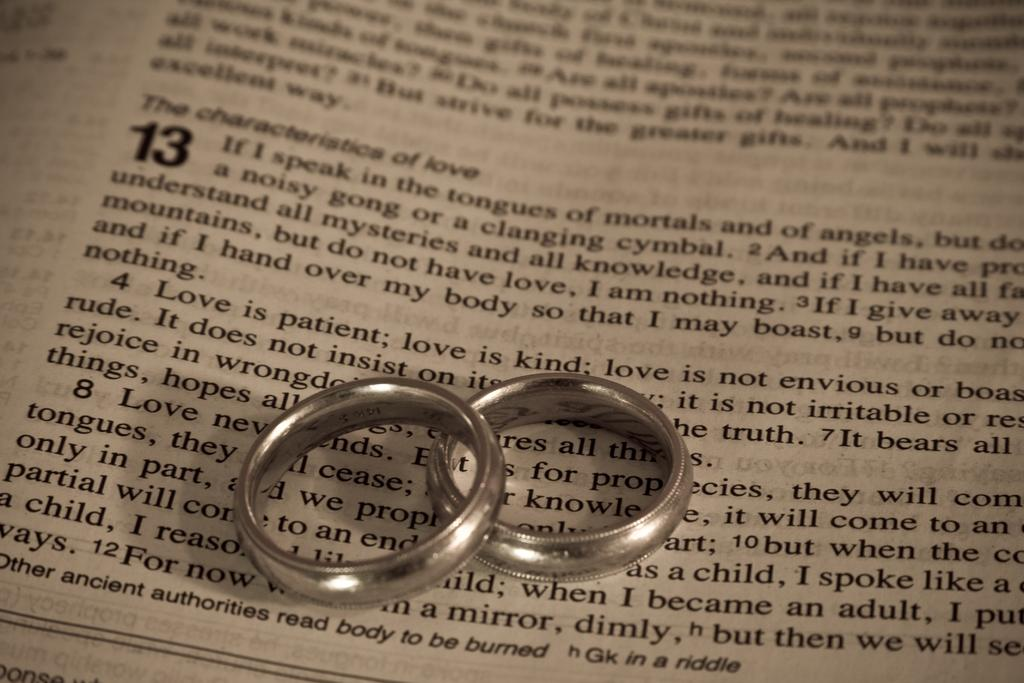<image>
Give a short and clear explanation of the subsequent image. The number 13 is on a printed page with a set of silver rings on top. 